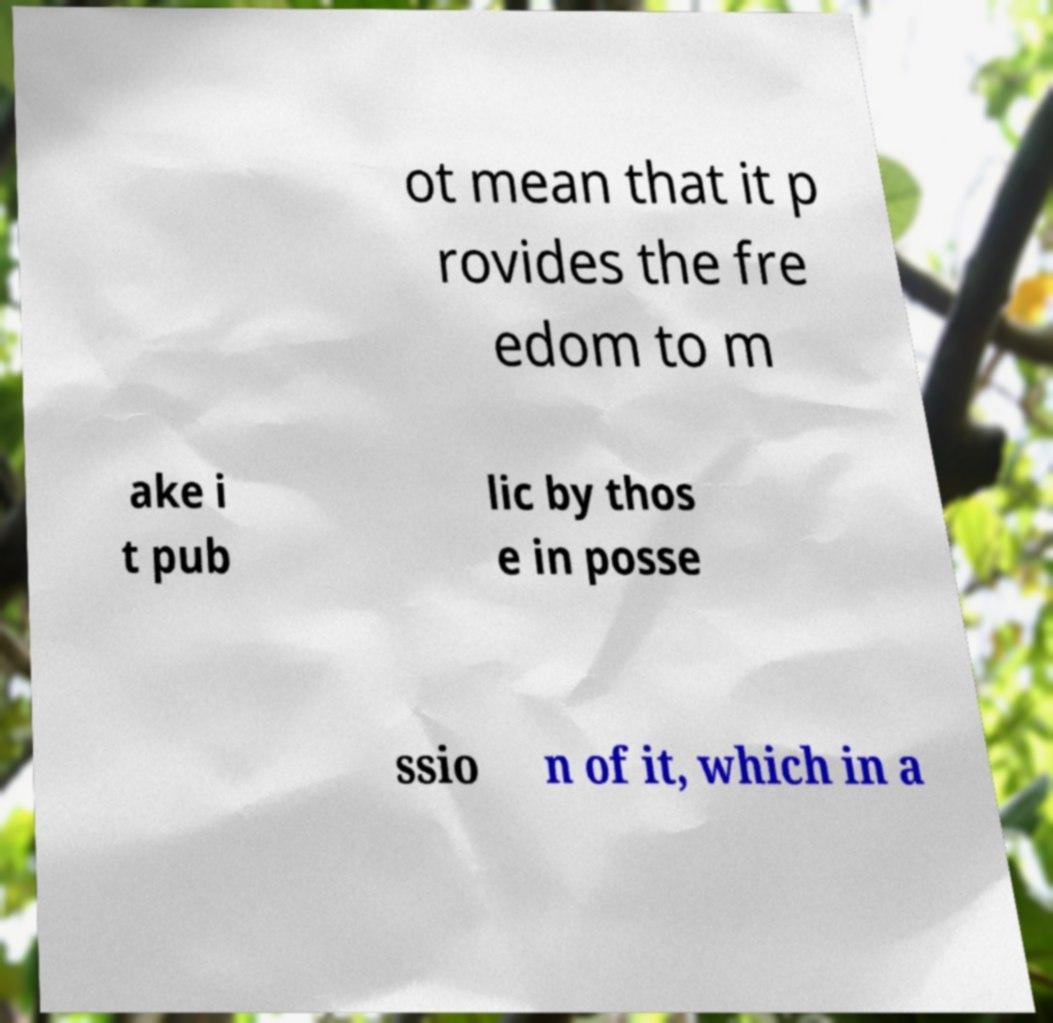There's text embedded in this image that I need extracted. Can you transcribe it verbatim? ot mean that it p rovides the fre edom to m ake i t pub lic by thos e in posse ssio n of it, which in a 